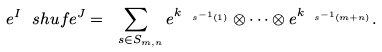Convert formula to latex. <formula><loc_0><loc_0><loc_500><loc_500>e ^ { I } \ s h u f e ^ { J } = \sum _ { \ s \in S _ { m , n } } e ^ { k _ { \ s ^ { - 1 } ( 1 ) } } \otimes \dots \otimes e ^ { k _ { \ s ^ { - 1 } ( m + n ) } } .</formula> 